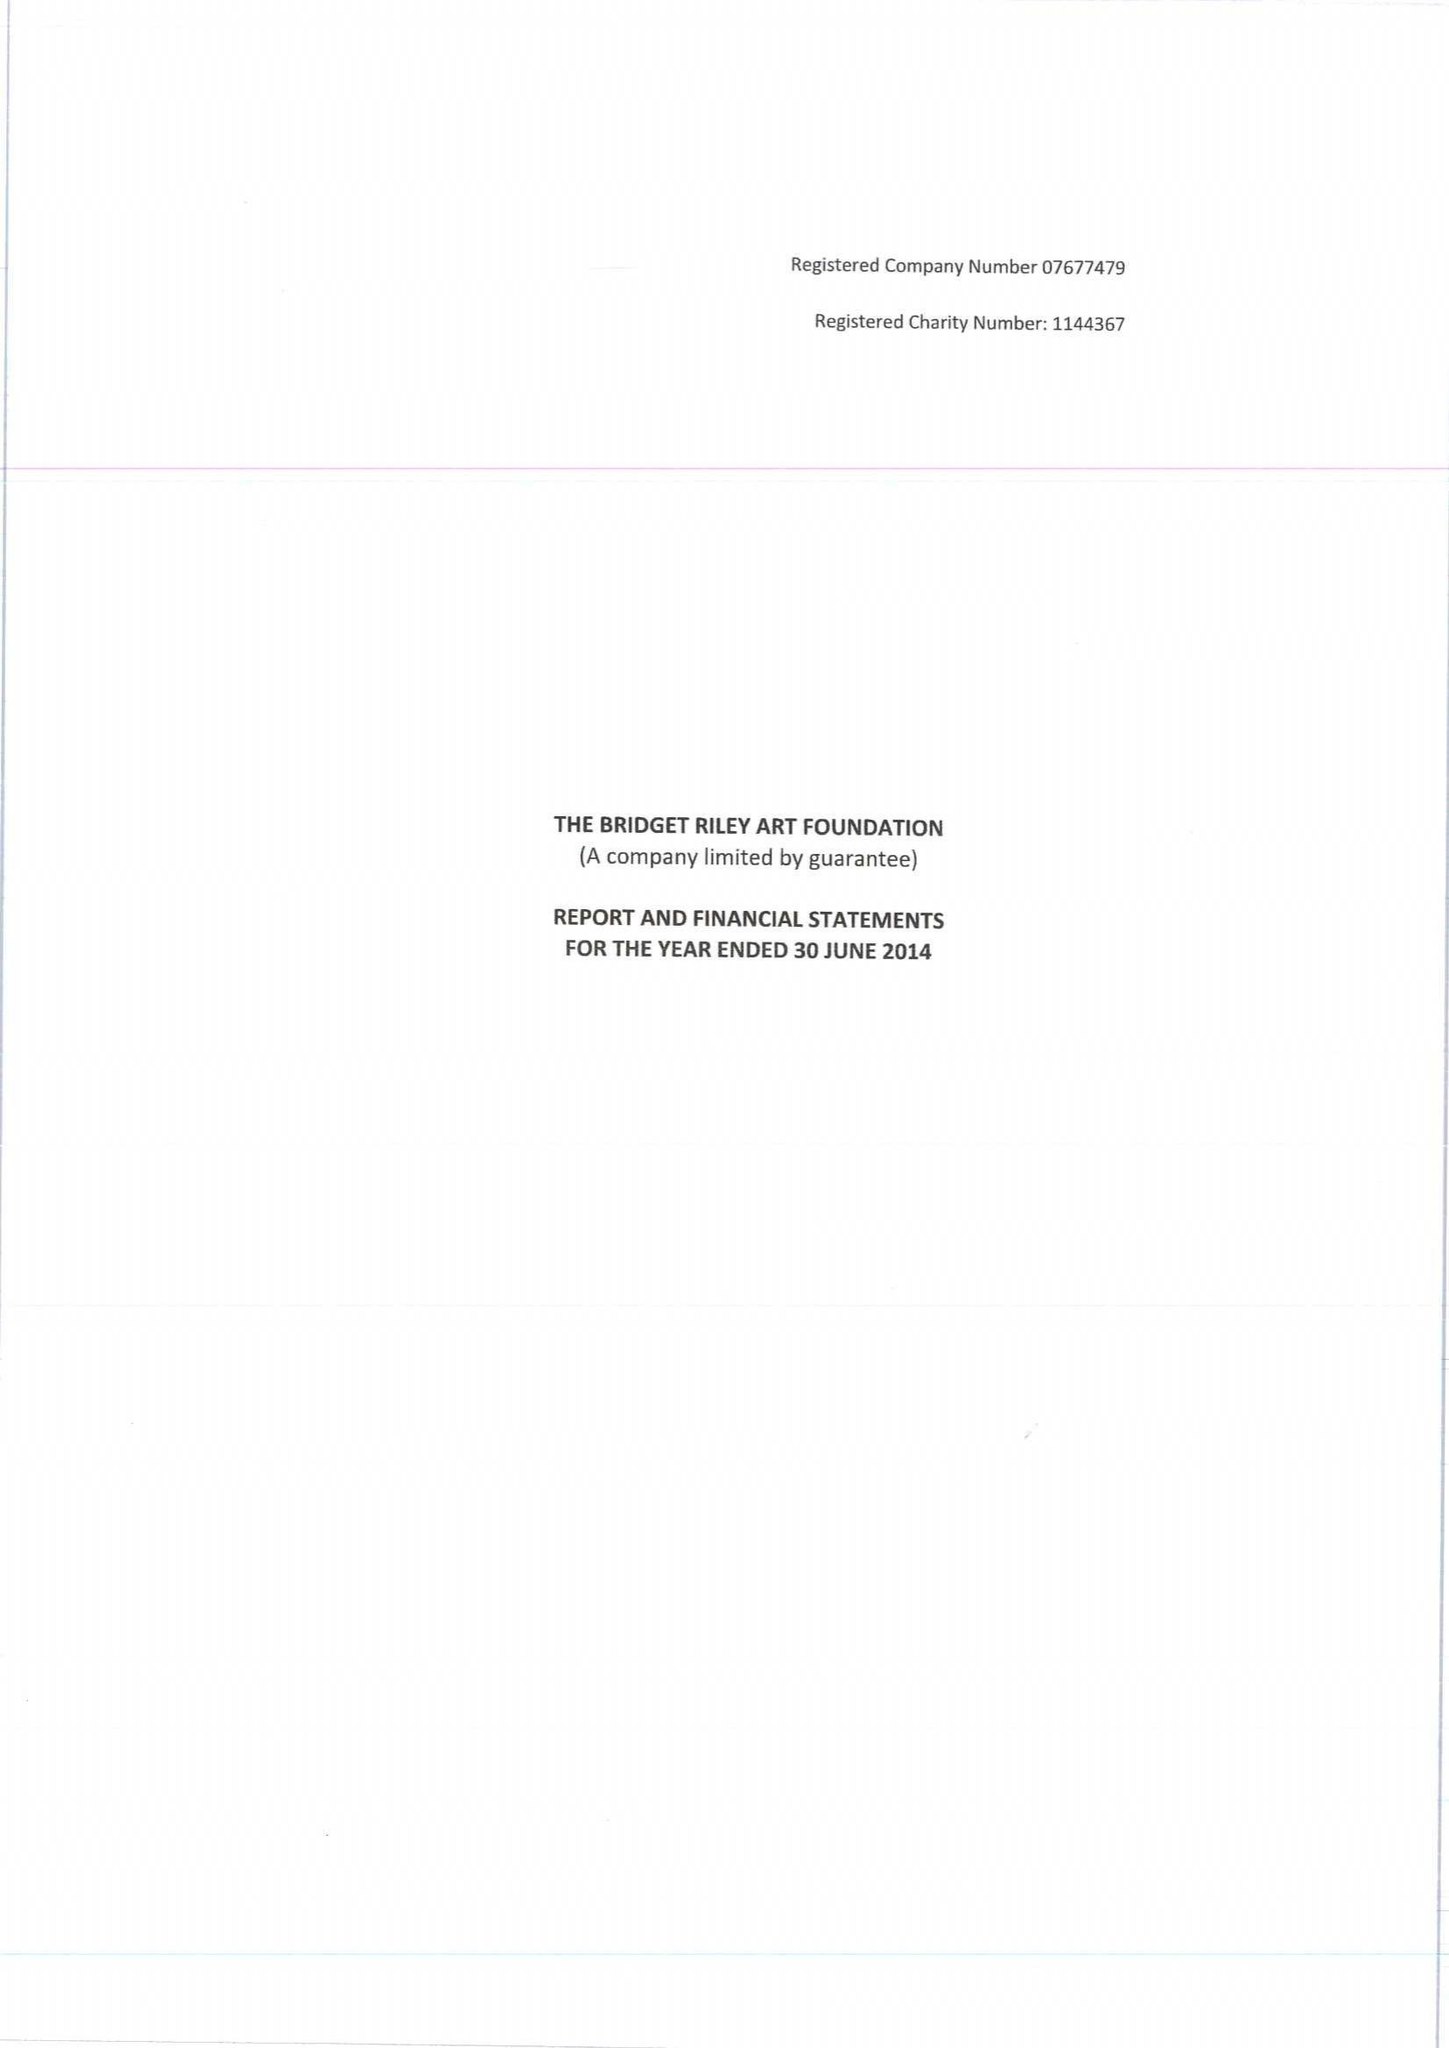What is the value for the address__post_town?
Answer the question using a single word or phrase. LONDON 